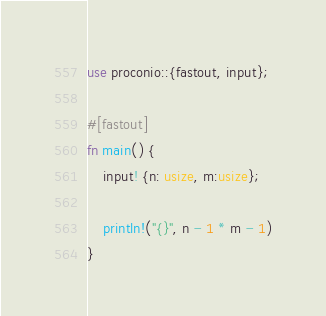Convert code to text. <code><loc_0><loc_0><loc_500><loc_500><_Rust_>use proconio::{fastout, input};

#[fastout]
fn main() {
    input! {n: usize, m:usize};

    println!("{}", n - 1 * m - 1)
}
</code> 